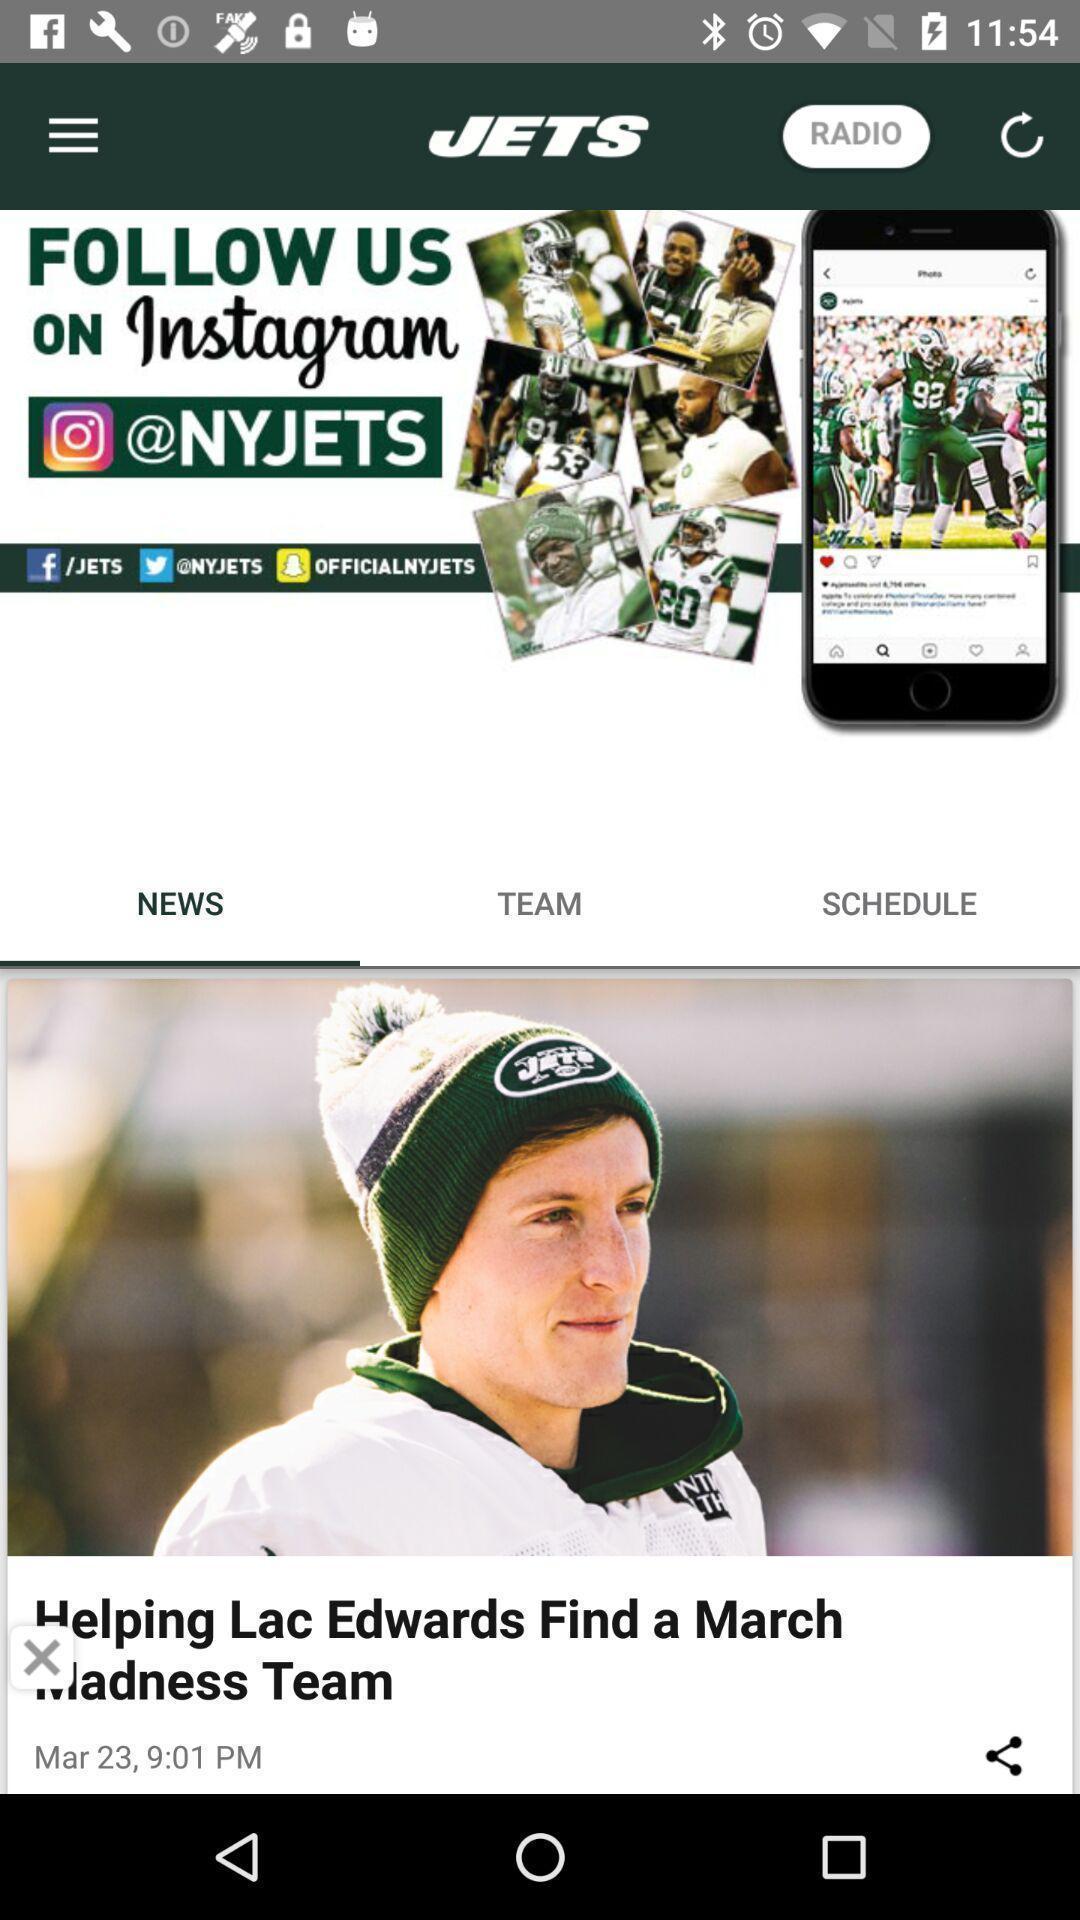What details can you identify in this image? Screen displaying news feed. 